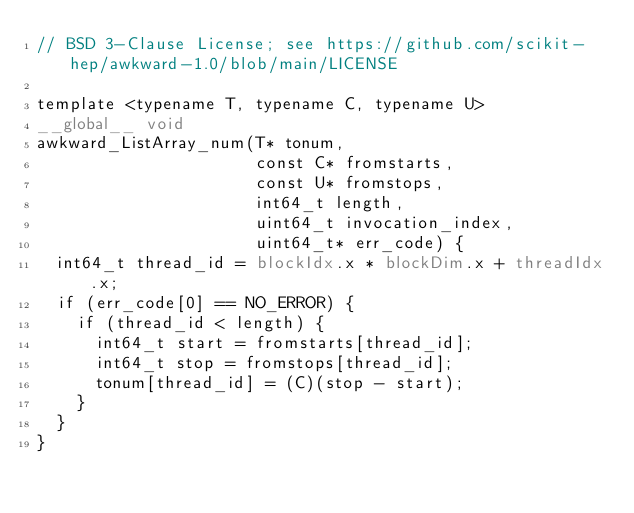Convert code to text. <code><loc_0><loc_0><loc_500><loc_500><_Cuda_>// BSD 3-Clause License; see https://github.com/scikit-hep/awkward-1.0/blob/main/LICENSE

template <typename T, typename C, typename U>
__global__ void
awkward_ListArray_num(T* tonum,
                      const C* fromstarts,
                      const U* fromstops,
                      int64_t length,
                      uint64_t invocation_index,
                      uint64_t* err_code) {
  int64_t thread_id = blockIdx.x * blockDim.x + threadIdx.x;
  if (err_code[0] == NO_ERROR) {
    if (thread_id < length) {
      int64_t start = fromstarts[thread_id];
      int64_t stop = fromstops[thread_id];
      tonum[thread_id] = (C)(stop - start);
    }
  }
}
</code> 